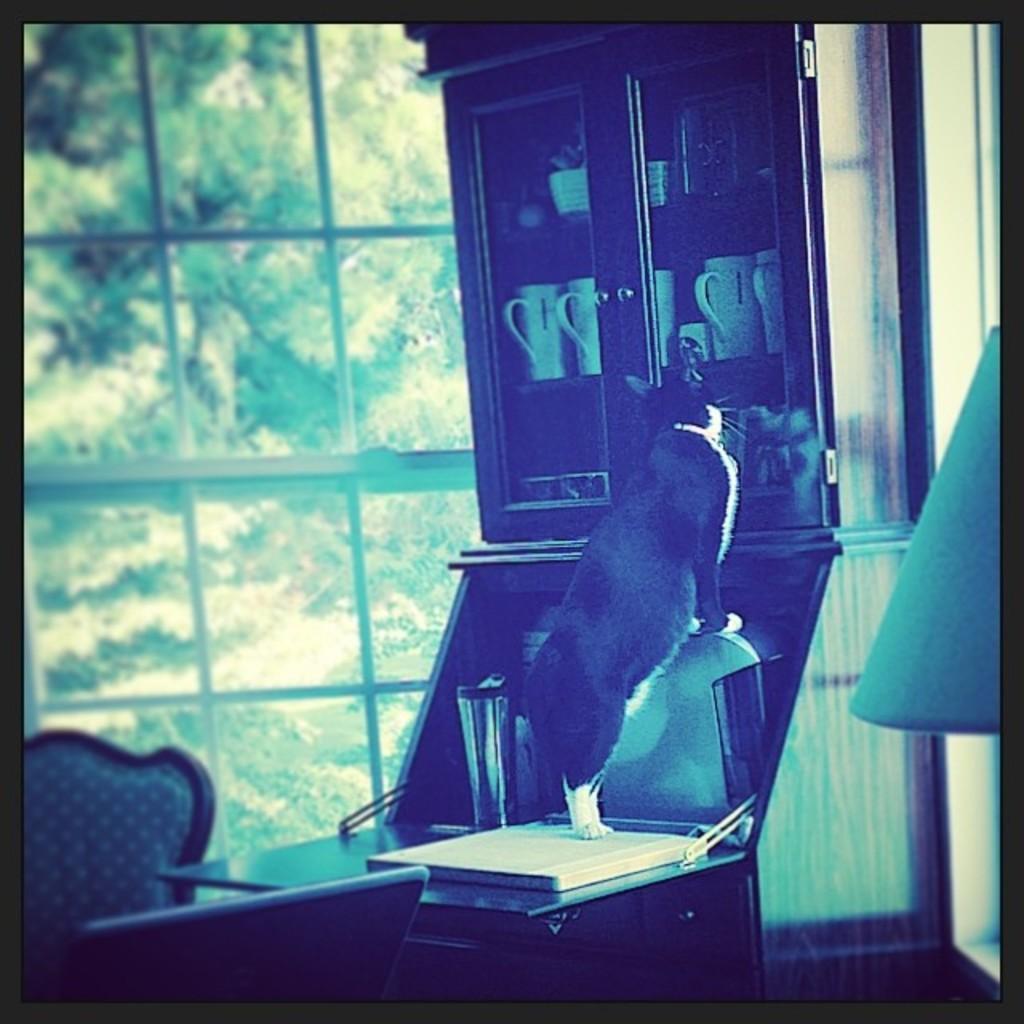How would you summarize this image in a sentence or two? This is an edited image and it is an inside view. In the middle of the image there is a cat standing on a table. Beside the table there is a rack in which few glasses and some other objects are placed. On the right side there is a lamp. In the bottom left there are two chairs. In the background there is a glass through which we can see the outside view. In the outside, I can see the trees. 